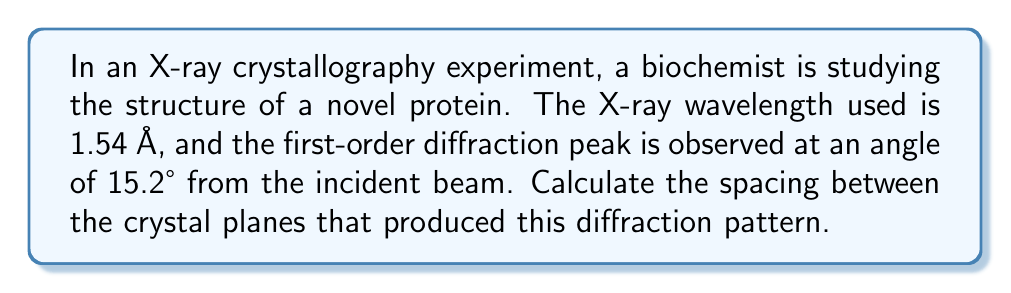Solve this math problem. To solve this problem, we'll use Bragg's Law, which describes the conditions for constructive interference in X-ray diffraction:

$$n\lambda = 2d\sin\theta$$

Where:
$n$ = order of diffraction (1 for first-order)
$\lambda$ = wavelength of X-rays
$d$ = spacing between crystal planes
$\theta$ = angle between incident beam and crystal plane

Step 1: Identify the given values
$n = 1$ (first-order diffraction)
$\lambda = 1.54$ Å
$\theta = 15.2°$ (half the angle between incident and diffracted beam)

Step 2: Rearrange Bragg's Law to solve for $d$
$$d = \frac{n\lambda}{2\sin\theta}$$

Step 3: Convert the angle to radians
$\theta_{rad} = 15.2° \times \frac{\pi}{180°} = 0.2653$ radians

Step 4: Substitute values and calculate
$$d = \frac{1 \times 1.54 \text{ Å}}{2\sin(0.2653)}$$
$$d = \frac{1.54 \text{ Å}}{2 \times 0.2624}$$
$$d = 2.93 \text{ Å}$$

Therefore, the spacing between the crystal planes is approximately 2.93 Å.
Answer: $2.93 \text{ Å}$ 